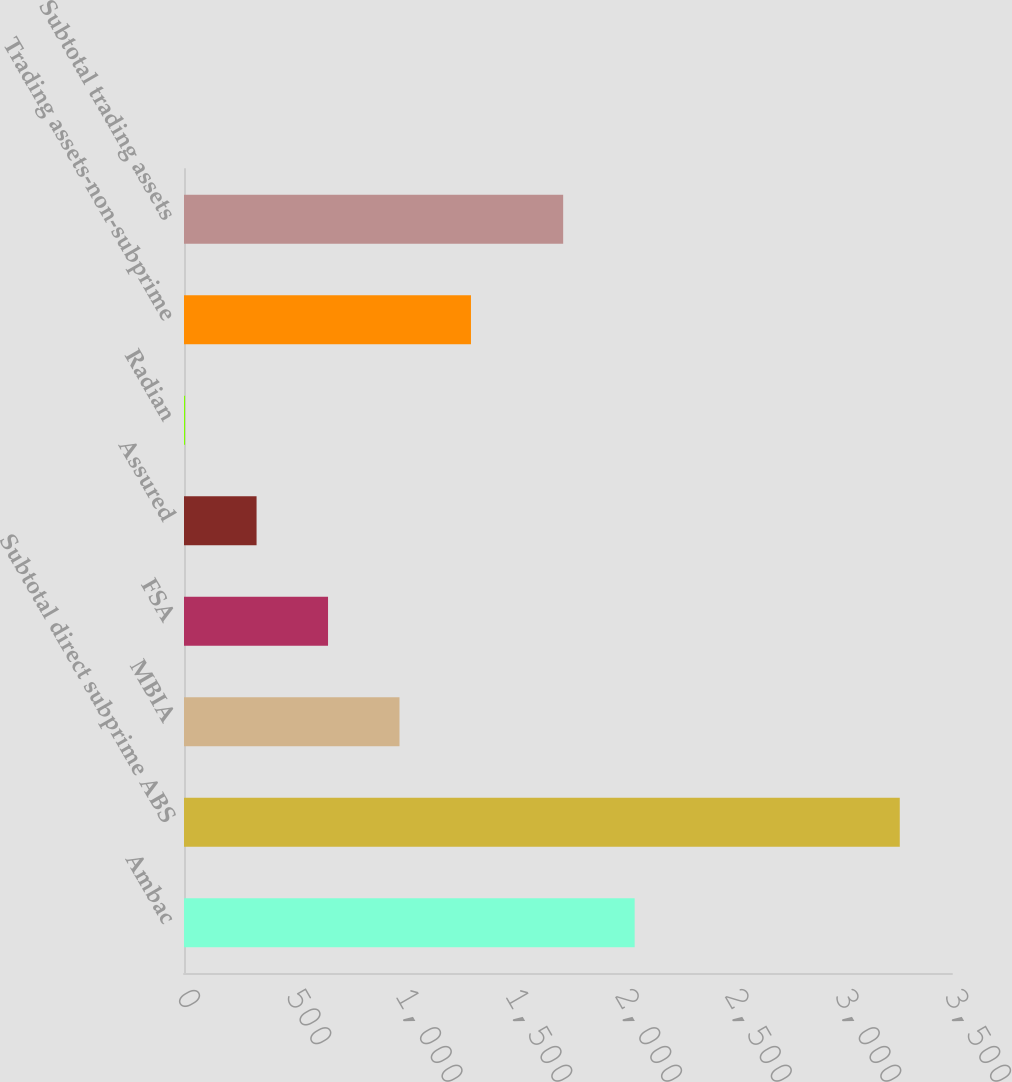<chart> <loc_0><loc_0><loc_500><loc_500><bar_chart><fcel>Ambac<fcel>Subtotal direct subprime ABS<fcel>MBIA<fcel>FSA<fcel>Assured<fcel>Radian<fcel>Trading assets-non-subprime<fcel>Subtotal trading assets<nl><fcel>2053.7<fcel>3262<fcel>982.1<fcel>656.4<fcel>330.7<fcel>5<fcel>1307.8<fcel>1728<nl></chart> 